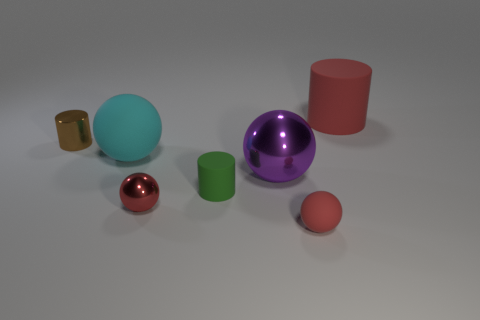What number of other things are the same color as the tiny metal cylinder?
Offer a terse response. 0. What color is the big thing that is both to the left of the large red object and on the right side of the small red metal ball?
Keep it short and to the point. Purple. How many large gray rubber blocks are there?
Your answer should be compact. 0. Does the small green object have the same material as the cyan thing?
Ensure brevity in your answer.  Yes. What is the shape of the big object that is to the right of the red matte object that is in front of the big matte object that is behind the small brown cylinder?
Keep it short and to the point. Cylinder. Is the red object that is right of the small matte ball made of the same material as the big ball right of the small red metal ball?
Ensure brevity in your answer.  No. What is the material of the big red thing?
Your response must be concise. Rubber. How many other things are the same shape as the big cyan matte thing?
Make the answer very short. 3. There is a large thing that is the same color as the small metallic ball; what material is it?
Keep it short and to the point. Rubber. Are there any other things that are the same shape as the green thing?
Provide a short and direct response. Yes. 